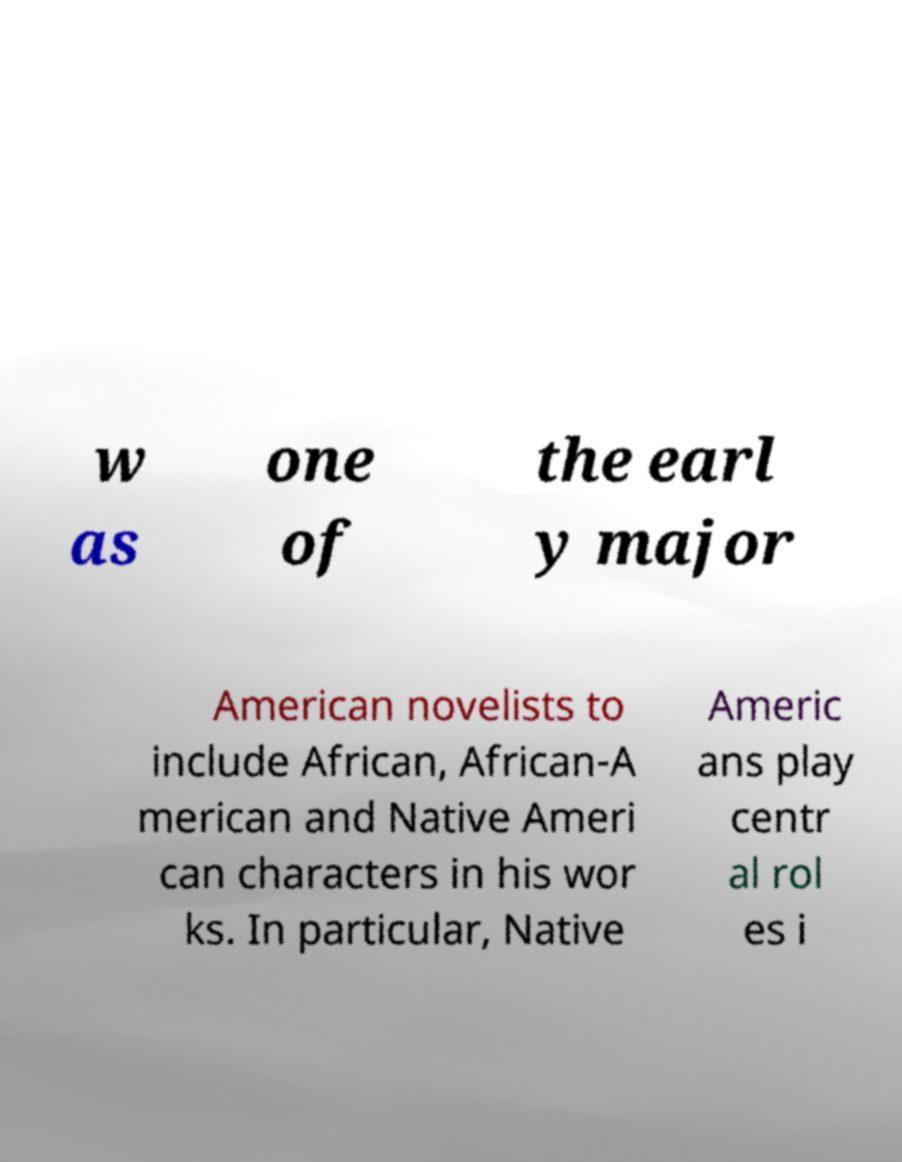Could you assist in decoding the text presented in this image and type it out clearly? w as one of the earl y major American novelists to include African, African-A merican and Native Ameri can characters in his wor ks. In particular, Native Americ ans play centr al rol es i 